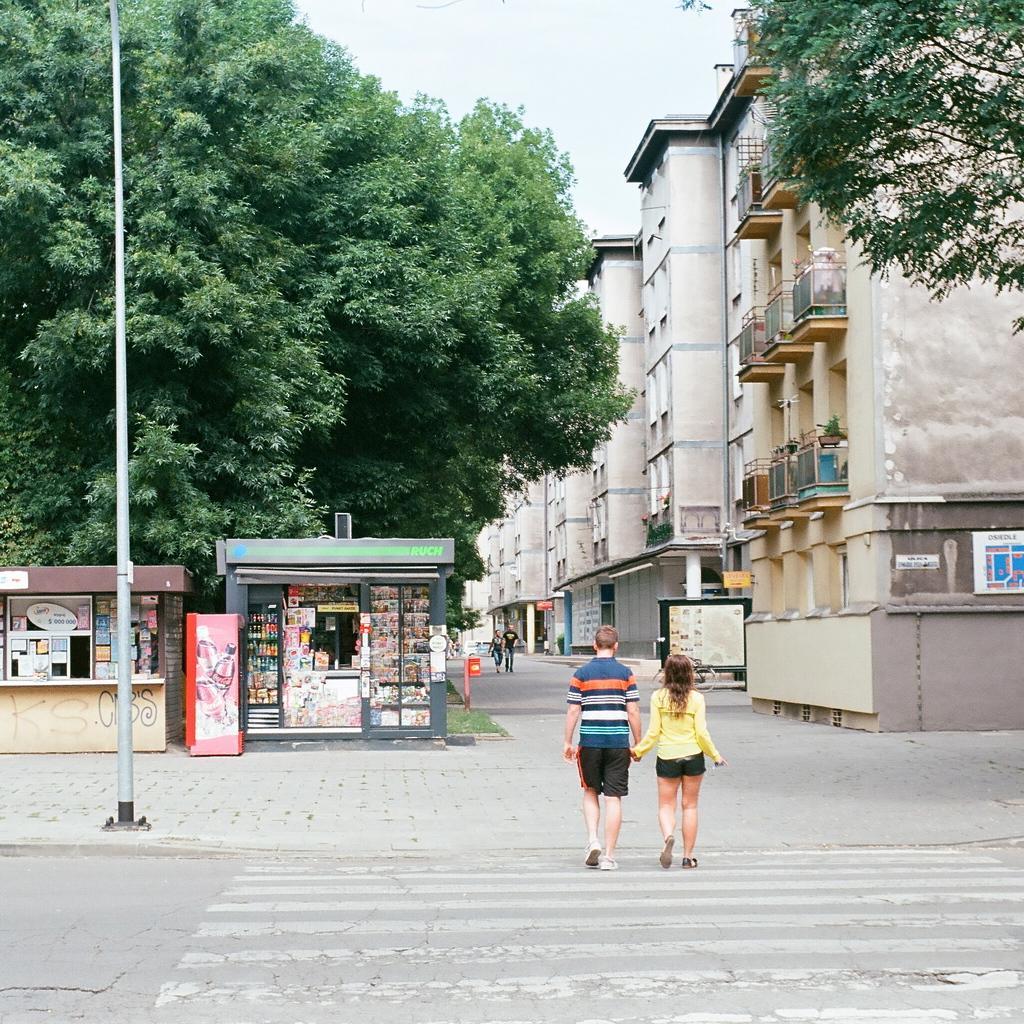Can you describe this image briefly? This image is taken outdoors. At the bottom of the image there is a road and a sidewalk. In the middle of the image a man and a woman are walking on the road. On the left side of the image there is a tree and two stools with many things and a board with text on it. On the right side of the image there are a few buildings with walls, windows, doors, pillars, balconies, railings and roofs and there is a tree. 